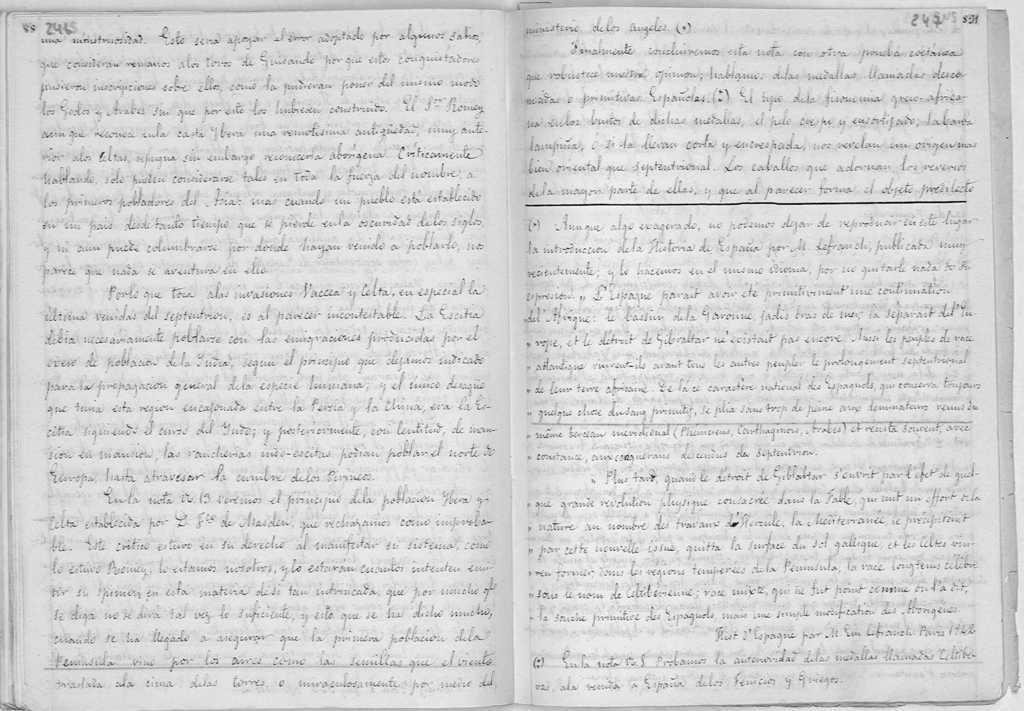In one or two sentences, can you explain what this image depicts? In this picture we can see some text in the paper. 